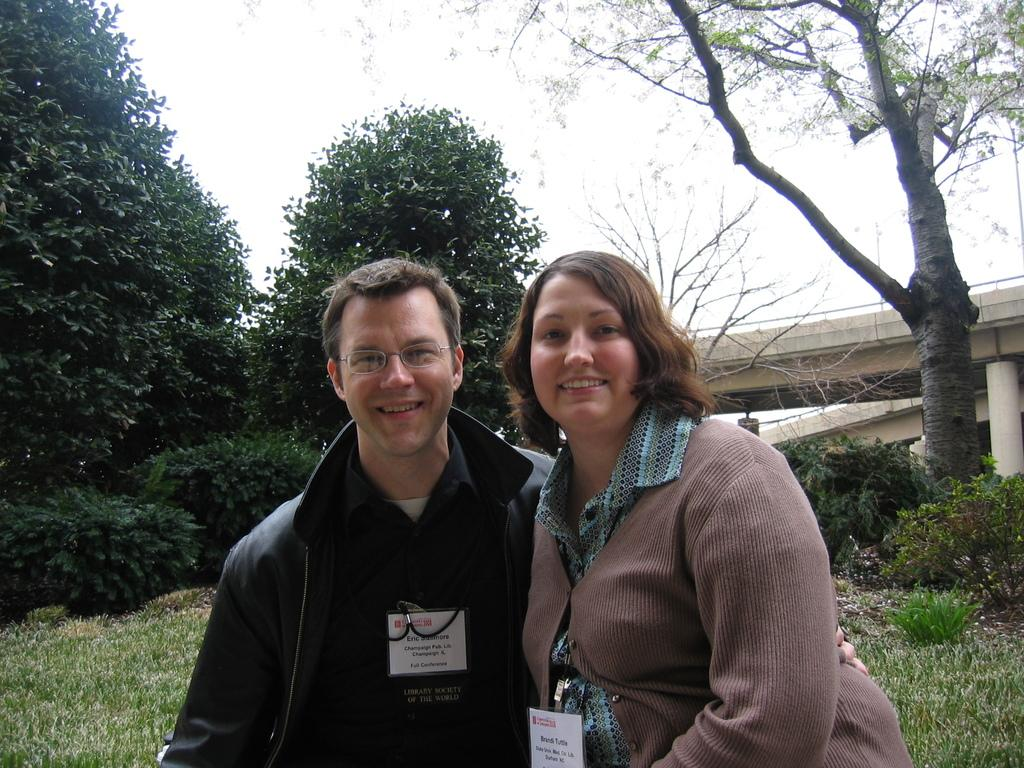How many people are in the image? There are two people in the image. What can be observed about the people's clothing? The people are wearing different color dresses. What is visible in the background of the image? There is a bridge and the sky in the background of the image. What type of mine can be seen in the image? There is no mine present in the image; it features two people and a bridge in the background. What hobbies do the people in the image have? The provided facts do not give any information about the people's hobbies, so we cannot determine that from the image. 